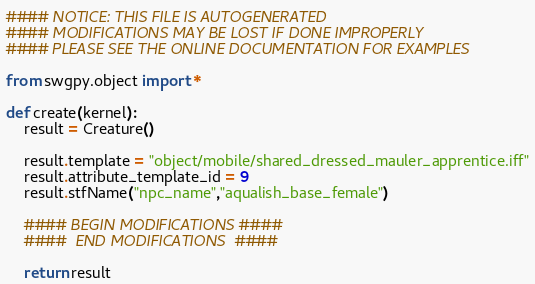Convert code to text. <code><loc_0><loc_0><loc_500><loc_500><_Python_>#### NOTICE: THIS FILE IS AUTOGENERATED
#### MODIFICATIONS MAY BE LOST IF DONE IMPROPERLY
#### PLEASE SEE THE ONLINE DOCUMENTATION FOR EXAMPLES

from swgpy.object import *	

def create(kernel):
	result = Creature()

	result.template = "object/mobile/shared_dressed_mauler_apprentice.iff"
	result.attribute_template_id = 9
	result.stfName("npc_name","aqualish_base_female")		
	
	#### BEGIN MODIFICATIONS ####
	####  END MODIFICATIONS  ####
	
	return result</code> 